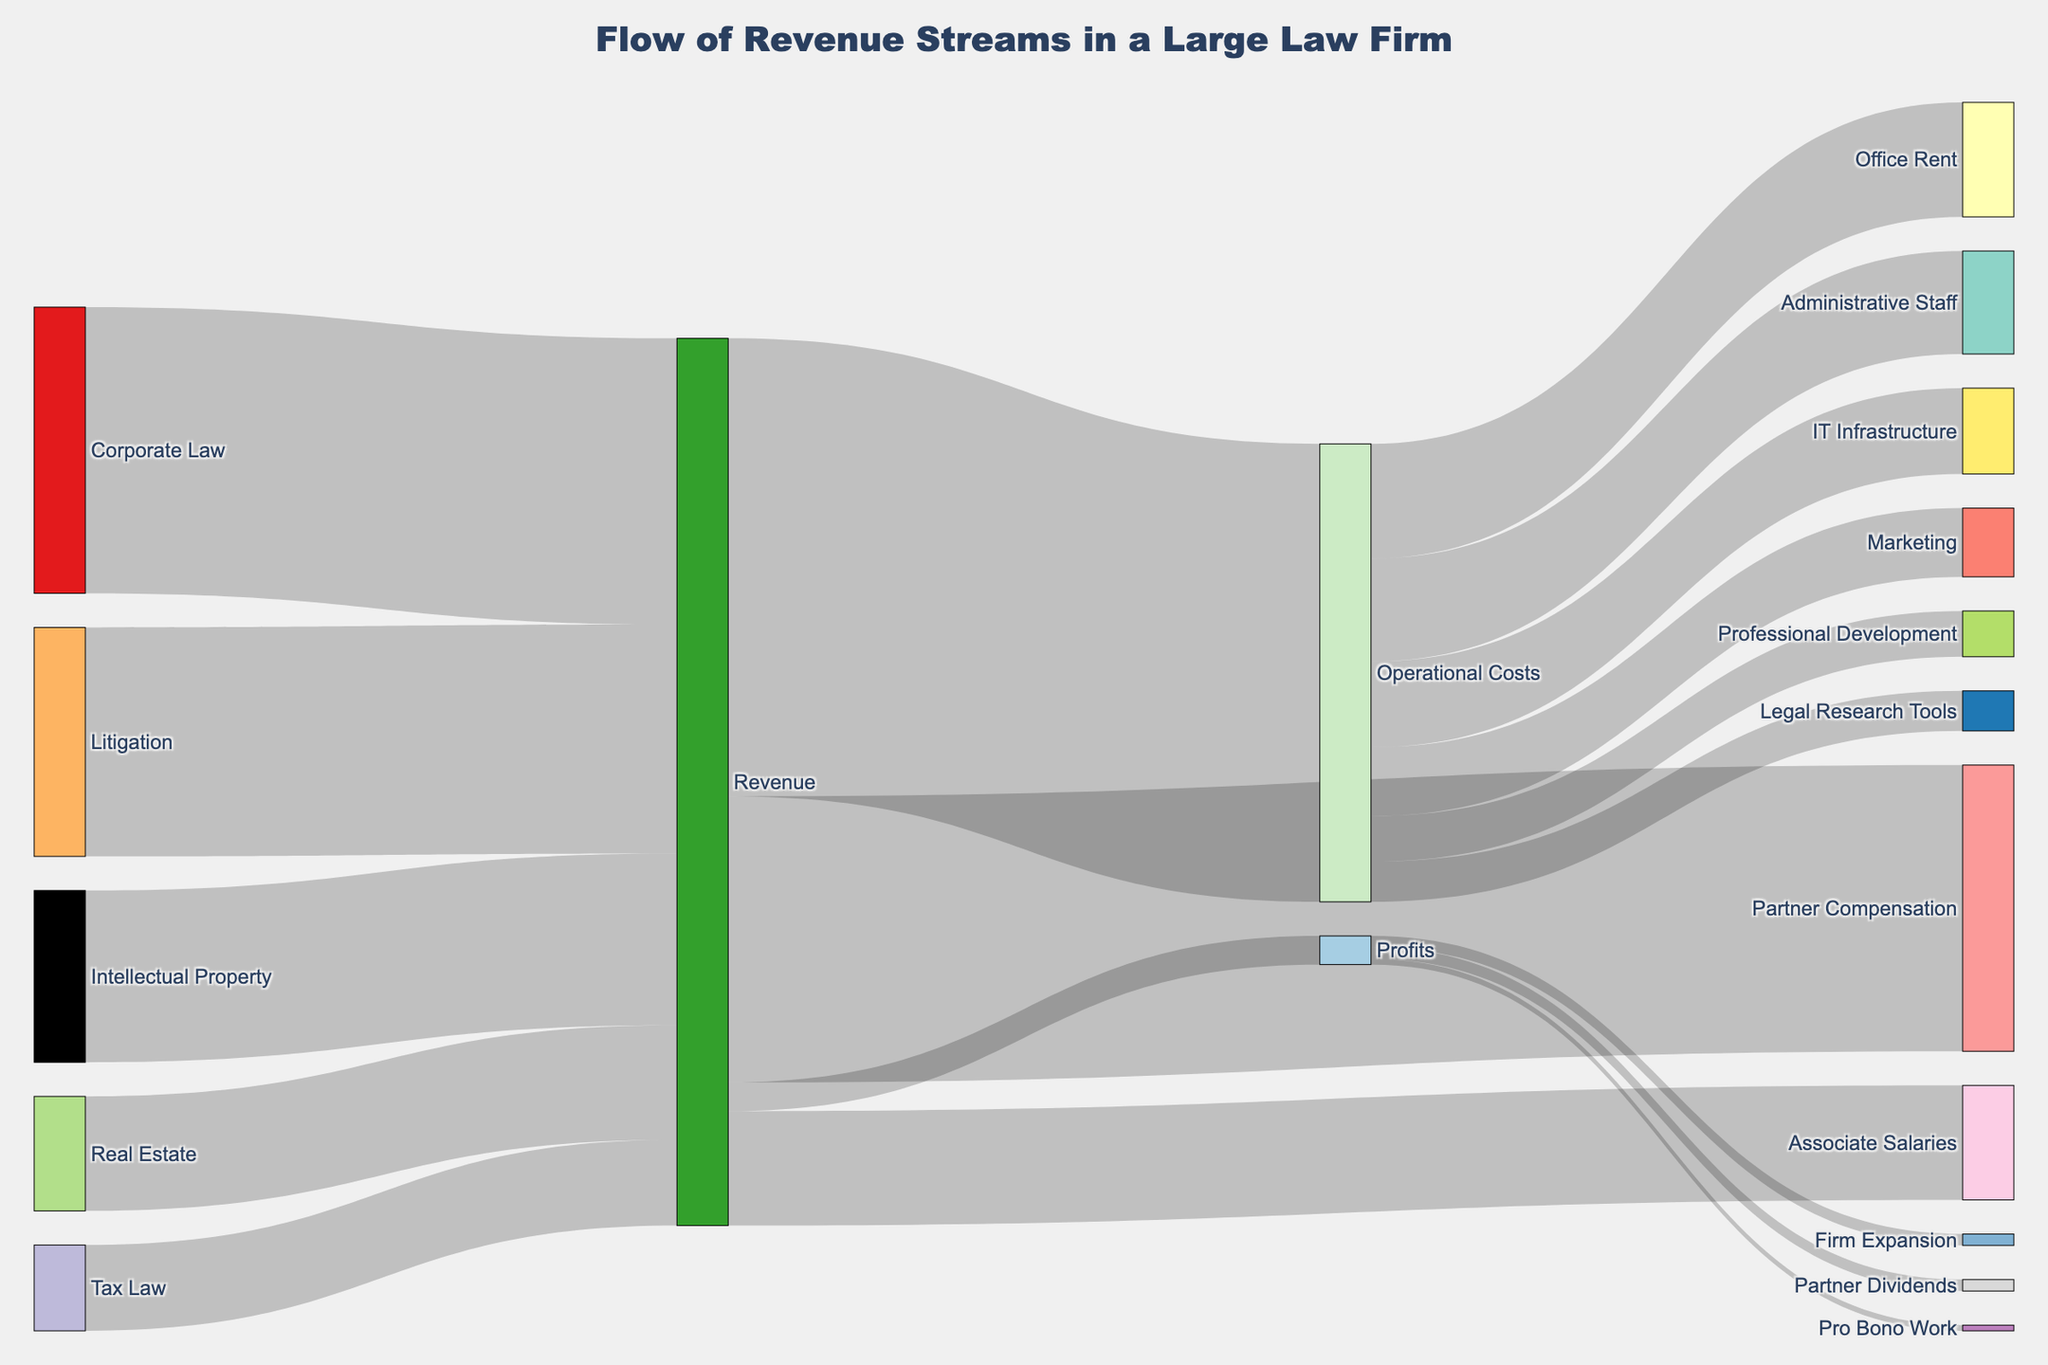How much revenue does Corporate Law generate for the firm? The Sankey diagram shows the revenue streams from different practice areas. Corporate Law's revenue stream is indicated by a flow labeled with its value.
Answer: $5,000,000 What is the total revenue generated by Litigation and Intellectual Property? To find the total revenue, sum the values from Litigation and Intellectual Property: $4,000,000 + $3,000,000.
Answer: $7,000,000 Which area among Real Estate and Tax Law contributes more to the firm's revenue? Compare the values of revenue from Real Estate and Tax Law. Real Estate shows $2,000,000, whereas Tax Law shows $1,500,000.
Answer: Real Estate How much of the revenue goes to Partner Compensation? The Sankey diagram shows the distribution of revenue, and Partner Compensation's share is labeled with its value.
Answer: $5,000,000 What percentage of the revenue is used for Operational Costs? To find the percentage, divide the value of Operational Costs by the total Revenue and multiply by 100: (8,000,000 / 15,500,000) * 100%.
Answer: 51.6% How does the expenditure on IT Infrastructure compare to Office Rent within Operational Costs? Compare the labeled flows of IT Infrastructure ($1,500,000) and Office Rent ($2,000,000).
Answer: Office Rent is greater If the revenue for Associate Salaries is increased by $1,000,000, what will be its new total? Add the increase to the current value: $2,000,000 + $1,000,000.
Answer: $3,000,000 Which operational cost component takes up the largest share? Identify the largest value within the operational costs. Office Rent shows the largest value of $2,000,000.
Answer: Office Rent How much of the profits are allocated to Firm Expansion? The Sankey diagram shows the division of profits, with Firm Expansion's share labeled with its value.
Answer: $200,000 What is the combined expenditure on Marketing and Legal Research Tools? Sum the values for Marketing and Legal Research Tools: $1,200,000 + $700,000.
Answer: $1,900,000 